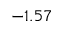Convert formula to latex. <formula><loc_0><loc_0><loc_500><loc_500>- 1 . 5 7</formula> 